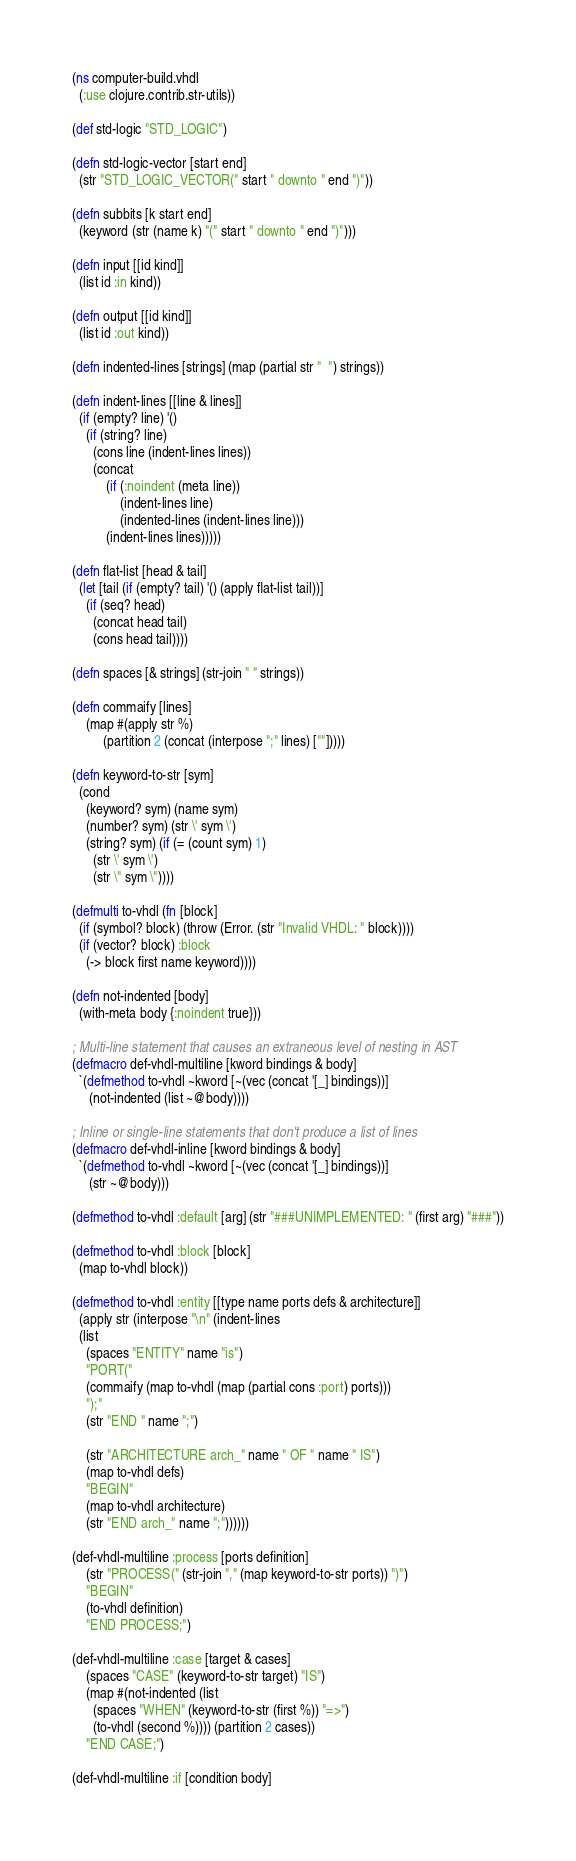Convert code to text. <code><loc_0><loc_0><loc_500><loc_500><_Clojure_>(ns computer-build.vhdl
  (:use clojure.contrib.str-utils))

(def std-logic "STD_LOGIC")

(defn std-logic-vector [start end]
  (str "STD_LOGIC_VECTOR(" start " downto " end ")"))

(defn subbits [k start end]
  (keyword (str (name k) "(" start " downto " end ")")))

(defn input [[id kind]]
  (list id :in kind))

(defn output [[id kind]]
  (list id :out kind))

(defn indented-lines [strings] (map (partial str "  ") strings))

(defn indent-lines [[line & lines]]
  (if (empty? line) '()
    (if (string? line)
      (cons line (indent-lines lines))
      (concat
          (if (:noindent (meta line))
              (indent-lines line)
              (indented-lines (indent-lines line)))
          (indent-lines lines)))))

(defn flat-list [head & tail]
  (let [tail (if (empty? tail) '() (apply flat-list tail))]
    (if (seq? head)
      (concat head tail)
      (cons head tail))))

(defn spaces [& strings] (str-join " " strings))

(defn commaify [lines]
    (map #(apply str %)
         (partition 2 (concat (interpose ";" lines) [""]))))

(defn keyword-to-str [sym]
  (cond
    (keyword? sym) (name sym)
    (number? sym) (str \' sym \')
    (string? sym) (if (= (count sym) 1)
      (str \' sym \')
      (str \" sym \"))))

(defmulti to-vhdl (fn [block]
  (if (symbol? block) (throw (Error. (str "Invalid VHDL: " block))))
  (if (vector? block) :block
    (-> block first name keyword))))

(defn not-indented [body]
  (with-meta body {:noindent true}))

; Multi-line statement that causes an extraneous level of nesting in AST
(defmacro def-vhdl-multiline [kword bindings & body]
  `(defmethod to-vhdl ~kword [~(vec (concat '[_] bindings))]
     (not-indented (list ~@body))))

; Inline or single-line statements that don't produce a list of lines
(defmacro def-vhdl-inline [kword bindings & body]
  `(defmethod to-vhdl ~kword [~(vec (concat '[_] bindings))]
     (str ~@body)))

(defmethod to-vhdl :default [arg] (str "###UNIMPLEMENTED: " (first arg) "###"))

(defmethod to-vhdl :block [block]
  (map to-vhdl block))

(defmethod to-vhdl :entity [[type name ports defs & architecture]]
  (apply str (interpose "\n" (indent-lines
  (list
    (spaces "ENTITY" name "is")
    "PORT("
    (commaify (map to-vhdl (map (partial cons :port) ports)))
    ");"
    (str "END " name ";")

    (str "ARCHITECTURE arch_" name " OF " name " IS")
    (map to-vhdl defs)
    "BEGIN"
    (map to-vhdl architecture)
    (str "END arch_" name ";"))))))

(def-vhdl-multiline :process [ports definition]
    (str "PROCESS(" (str-join "," (map keyword-to-str ports)) ")")
    "BEGIN"
    (to-vhdl definition)
    "END PROCESS;")

(def-vhdl-multiline :case [target & cases]
    (spaces "CASE" (keyword-to-str target) "IS")
    (map #(not-indented (list
      (spaces "WHEN" (keyword-to-str (first %)) "=>")
      (to-vhdl (second %)))) (partition 2 cases))
    "END CASE;")

(def-vhdl-multiline :if [condition body]</code> 